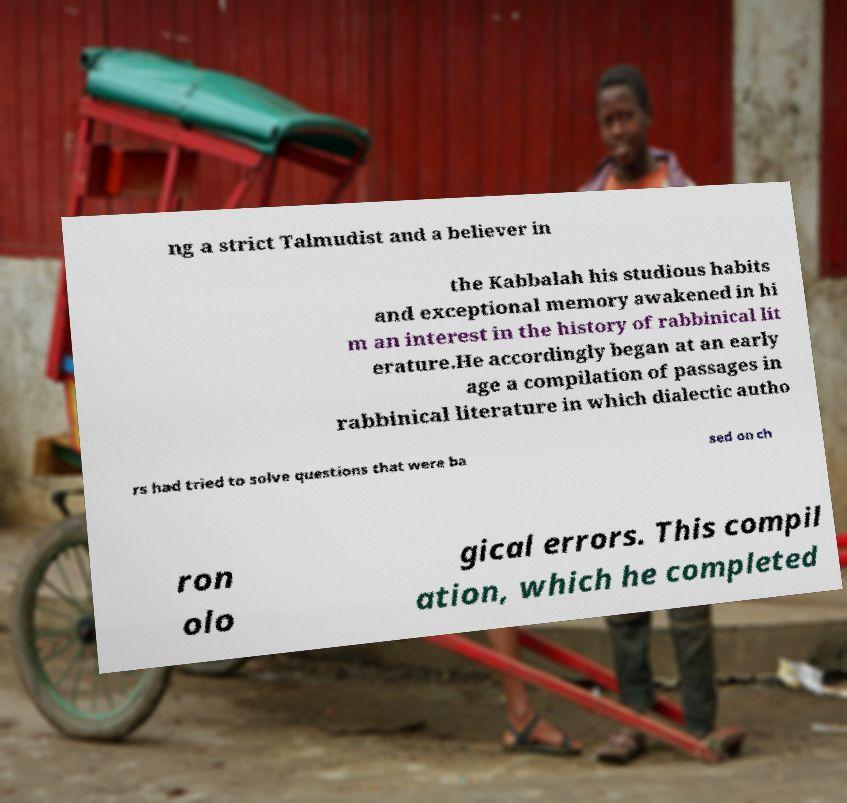Please read and relay the text visible in this image. What does it say? ng a strict Talmudist and a believer in the Kabbalah his studious habits and exceptional memory awakened in hi m an interest in the history of rabbinical lit erature.He accordingly began at an early age a compilation of passages in rabbinical literature in which dialectic autho rs had tried to solve questions that were ba sed on ch ron olo gical errors. This compil ation, which he completed 